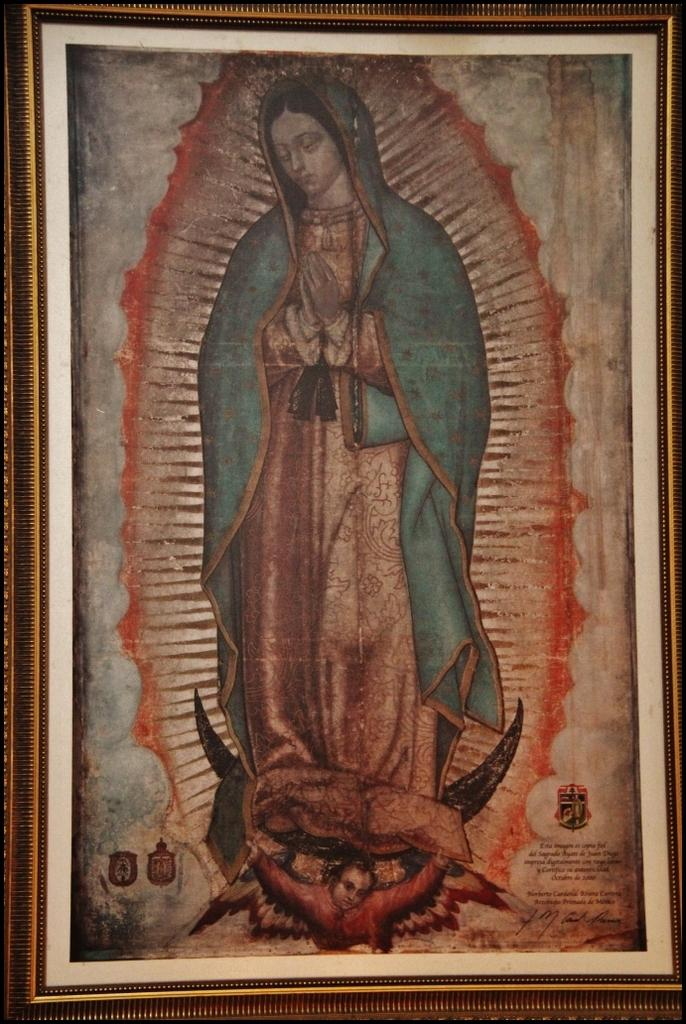What is the main subject of the image? The main subject of the image is a photo frame. What can be seen inside the photo frame? There is a painting inside the photo frame. What does the painting depict? The painting depicts a lady and a child. Is there any text on the painting? Yes, there is writing on the painting. How much honey is being used in the painting? There is no honey present in the painting; it depicts a lady and a child. What type of party is being held in the painting? There is no party depicted in the painting; it only shows a lady and a child. 